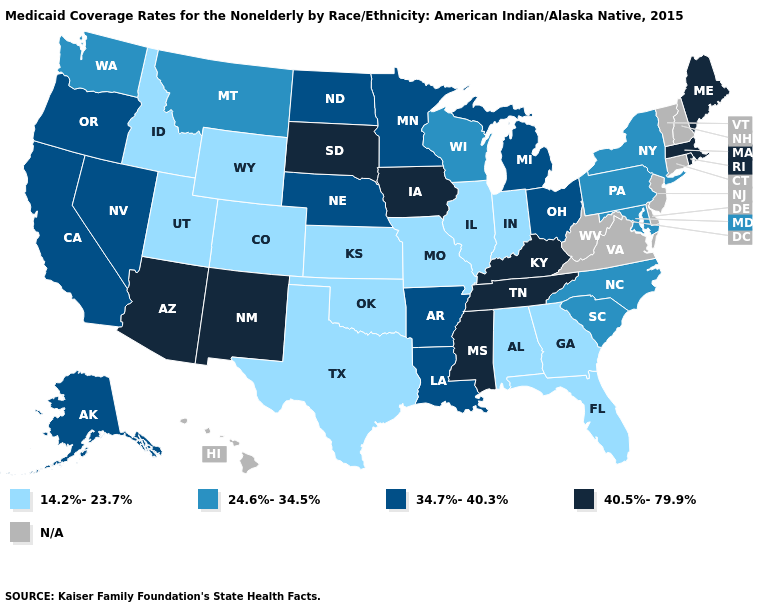Does Wyoming have the lowest value in the USA?
Answer briefly. Yes. Which states have the highest value in the USA?
Be succinct. Arizona, Iowa, Kentucky, Maine, Massachusetts, Mississippi, New Mexico, Rhode Island, South Dakota, Tennessee. Name the states that have a value in the range 14.2%-23.7%?
Short answer required. Alabama, Colorado, Florida, Georgia, Idaho, Illinois, Indiana, Kansas, Missouri, Oklahoma, Texas, Utah, Wyoming. Name the states that have a value in the range 14.2%-23.7%?
Answer briefly. Alabama, Colorado, Florida, Georgia, Idaho, Illinois, Indiana, Kansas, Missouri, Oklahoma, Texas, Utah, Wyoming. Which states have the lowest value in the Northeast?
Concise answer only. New York, Pennsylvania. What is the value of Nebraska?
Quick response, please. 34.7%-40.3%. What is the lowest value in states that border Rhode Island?
Keep it brief. 40.5%-79.9%. Which states hav the highest value in the South?
Answer briefly. Kentucky, Mississippi, Tennessee. Does Arizona have the highest value in the West?
Short answer required. Yes. Among the states that border North Dakota , does Montana have the lowest value?
Quick response, please. Yes. Does the map have missing data?
Short answer required. Yes. Which states hav the highest value in the West?
Short answer required. Arizona, New Mexico. Which states have the highest value in the USA?
Quick response, please. Arizona, Iowa, Kentucky, Maine, Massachusetts, Mississippi, New Mexico, Rhode Island, South Dakota, Tennessee. What is the highest value in the Northeast ?
Answer briefly. 40.5%-79.9%. 